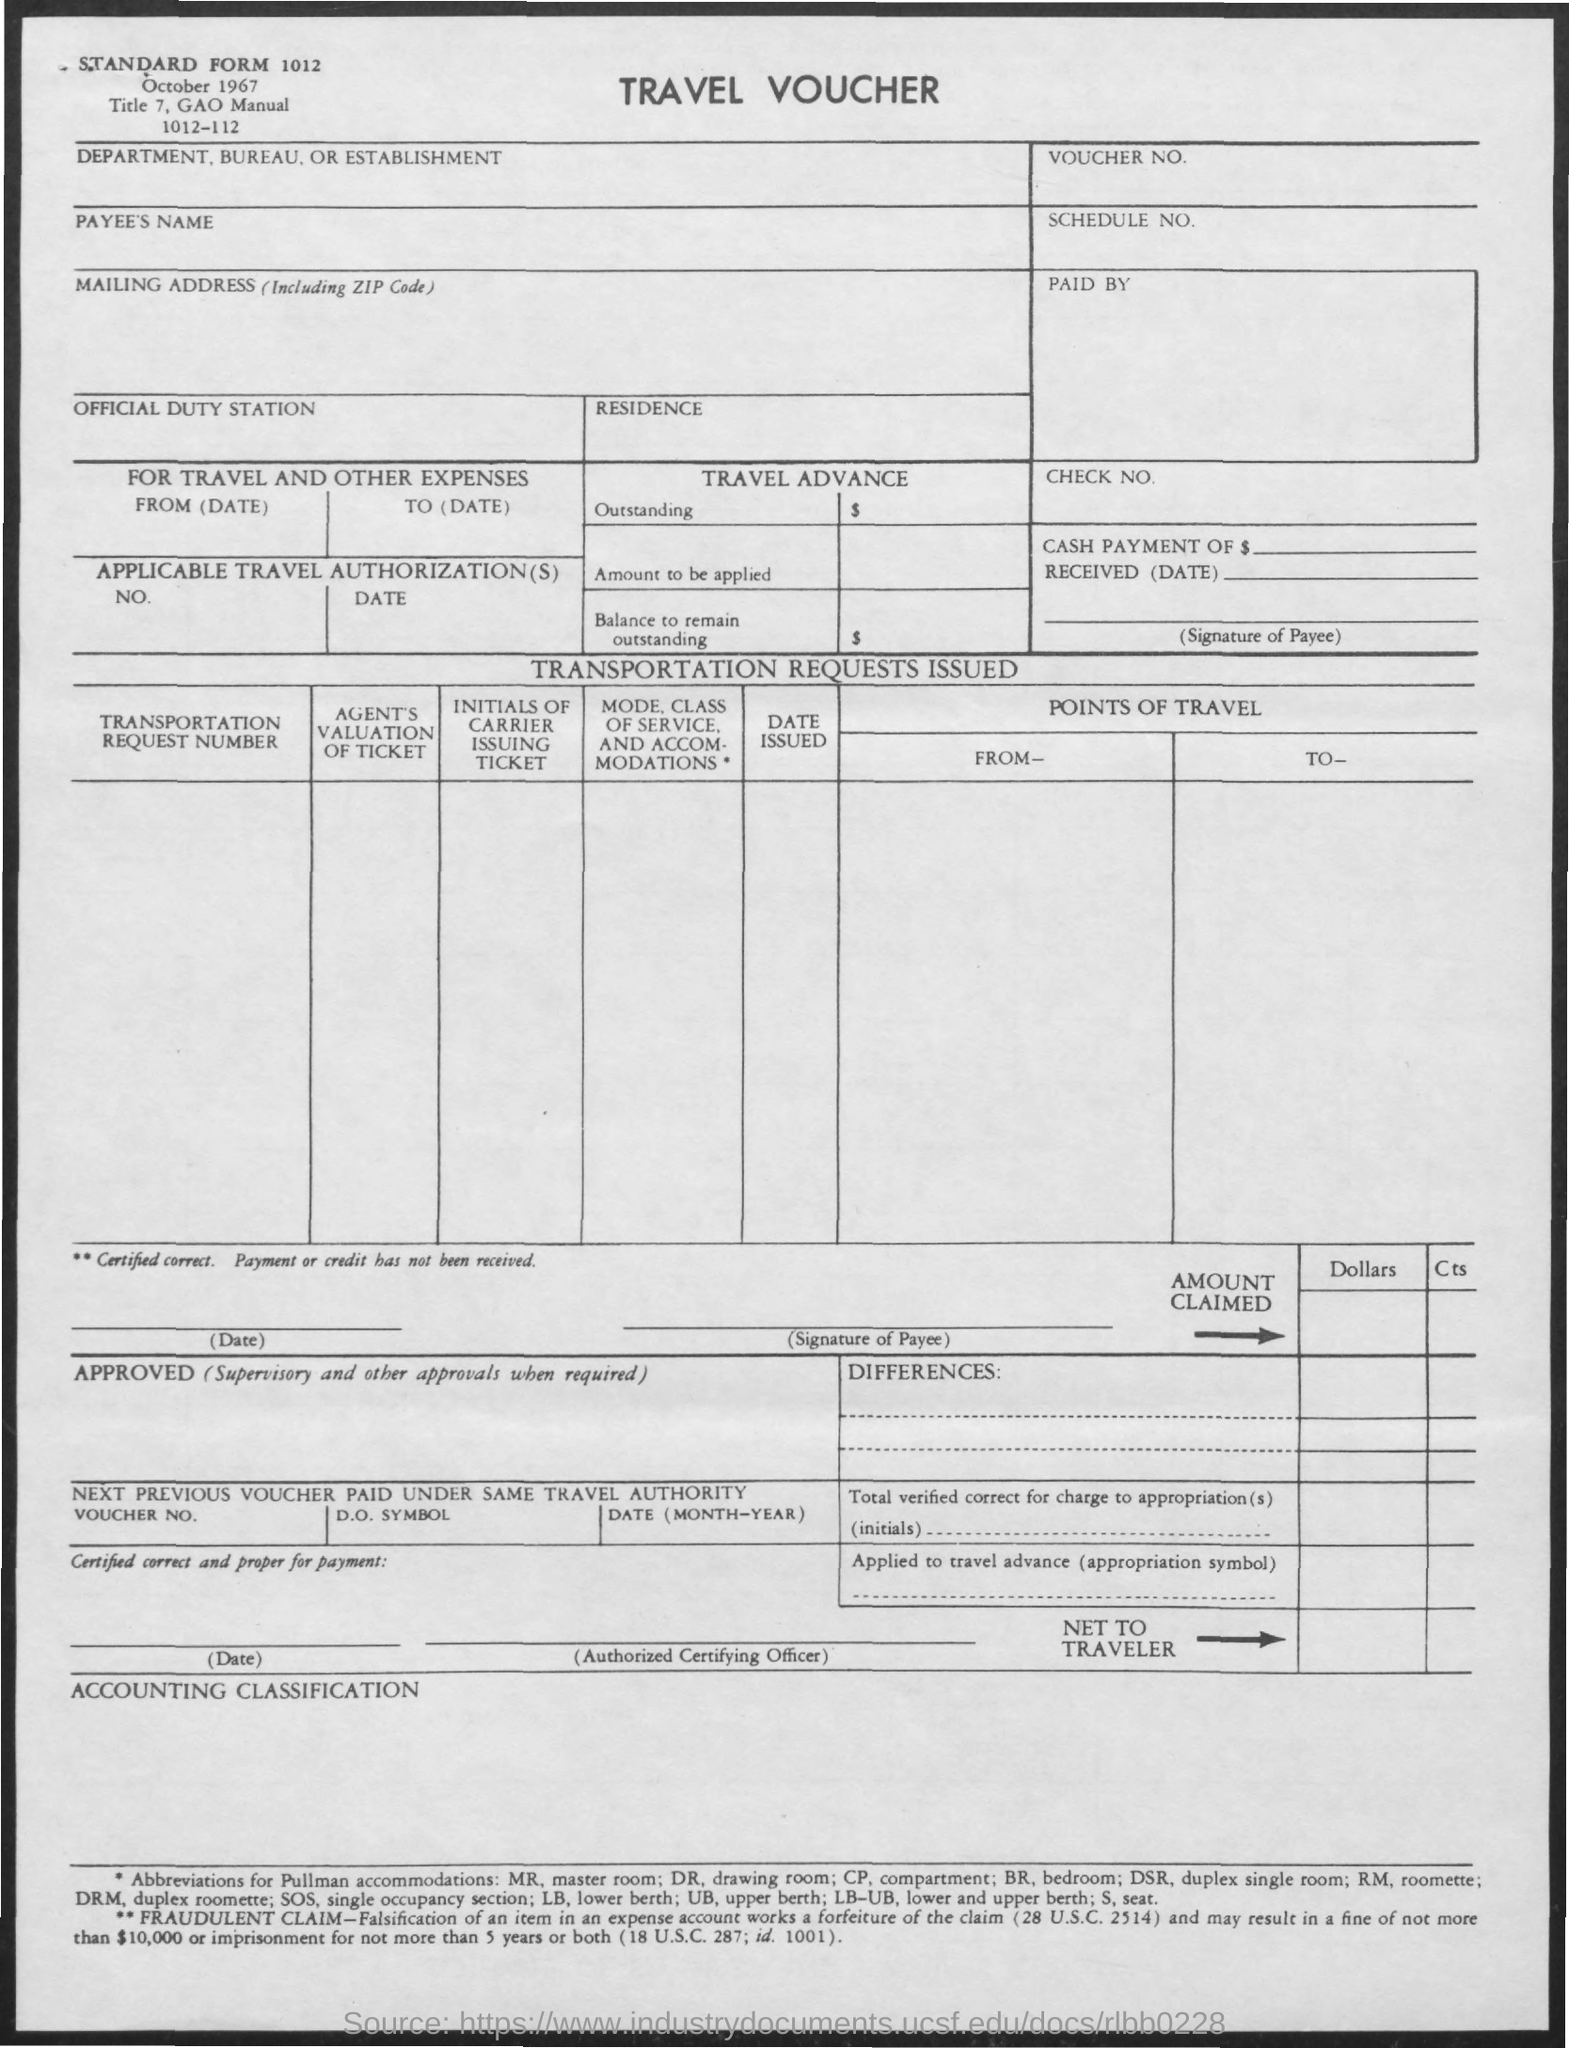Draw attention to some important aspects in this diagram. The standard form number listed on the travel voucher is 1012. I am declaring that the type of voucher being referred to is a travel voucher. 